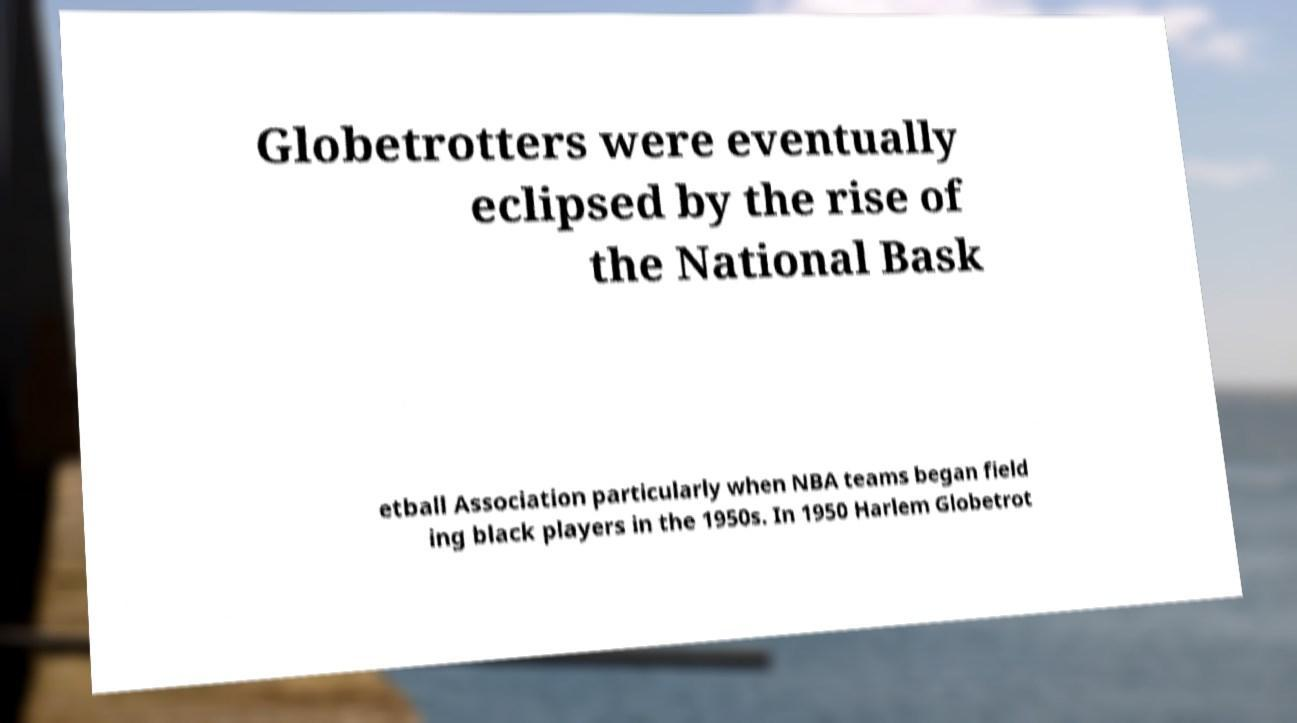Please identify and transcribe the text found in this image. Globetrotters were eventually eclipsed by the rise of the National Bask etball Association particularly when NBA teams began field ing black players in the 1950s. In 1950 Harlem Globetrot 